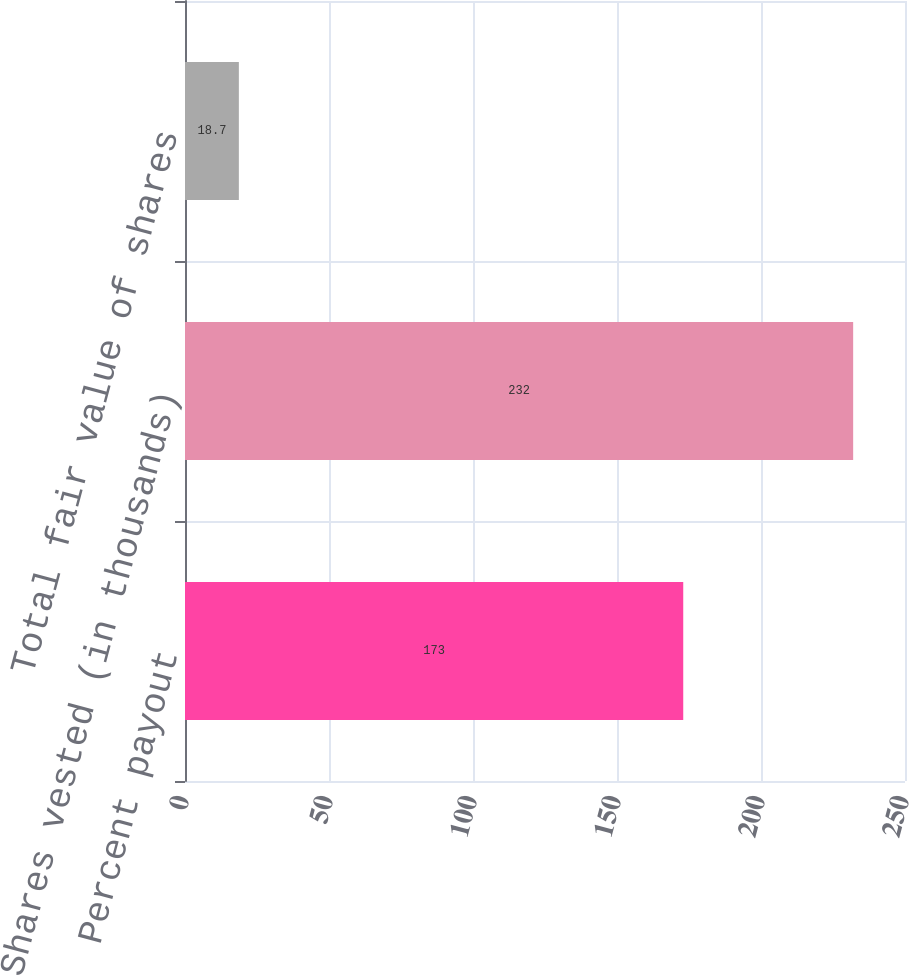Convert chart to OTSL. <chart><loc_0><loc_0><loc_500><loc_500><bar_chart><fcel>Percent payout<fcel>Shares vested (in thousands)<fcel>Total fair value of shares<nl><fcel>173<fcel>232<fcel>18.7<nl></chart> 